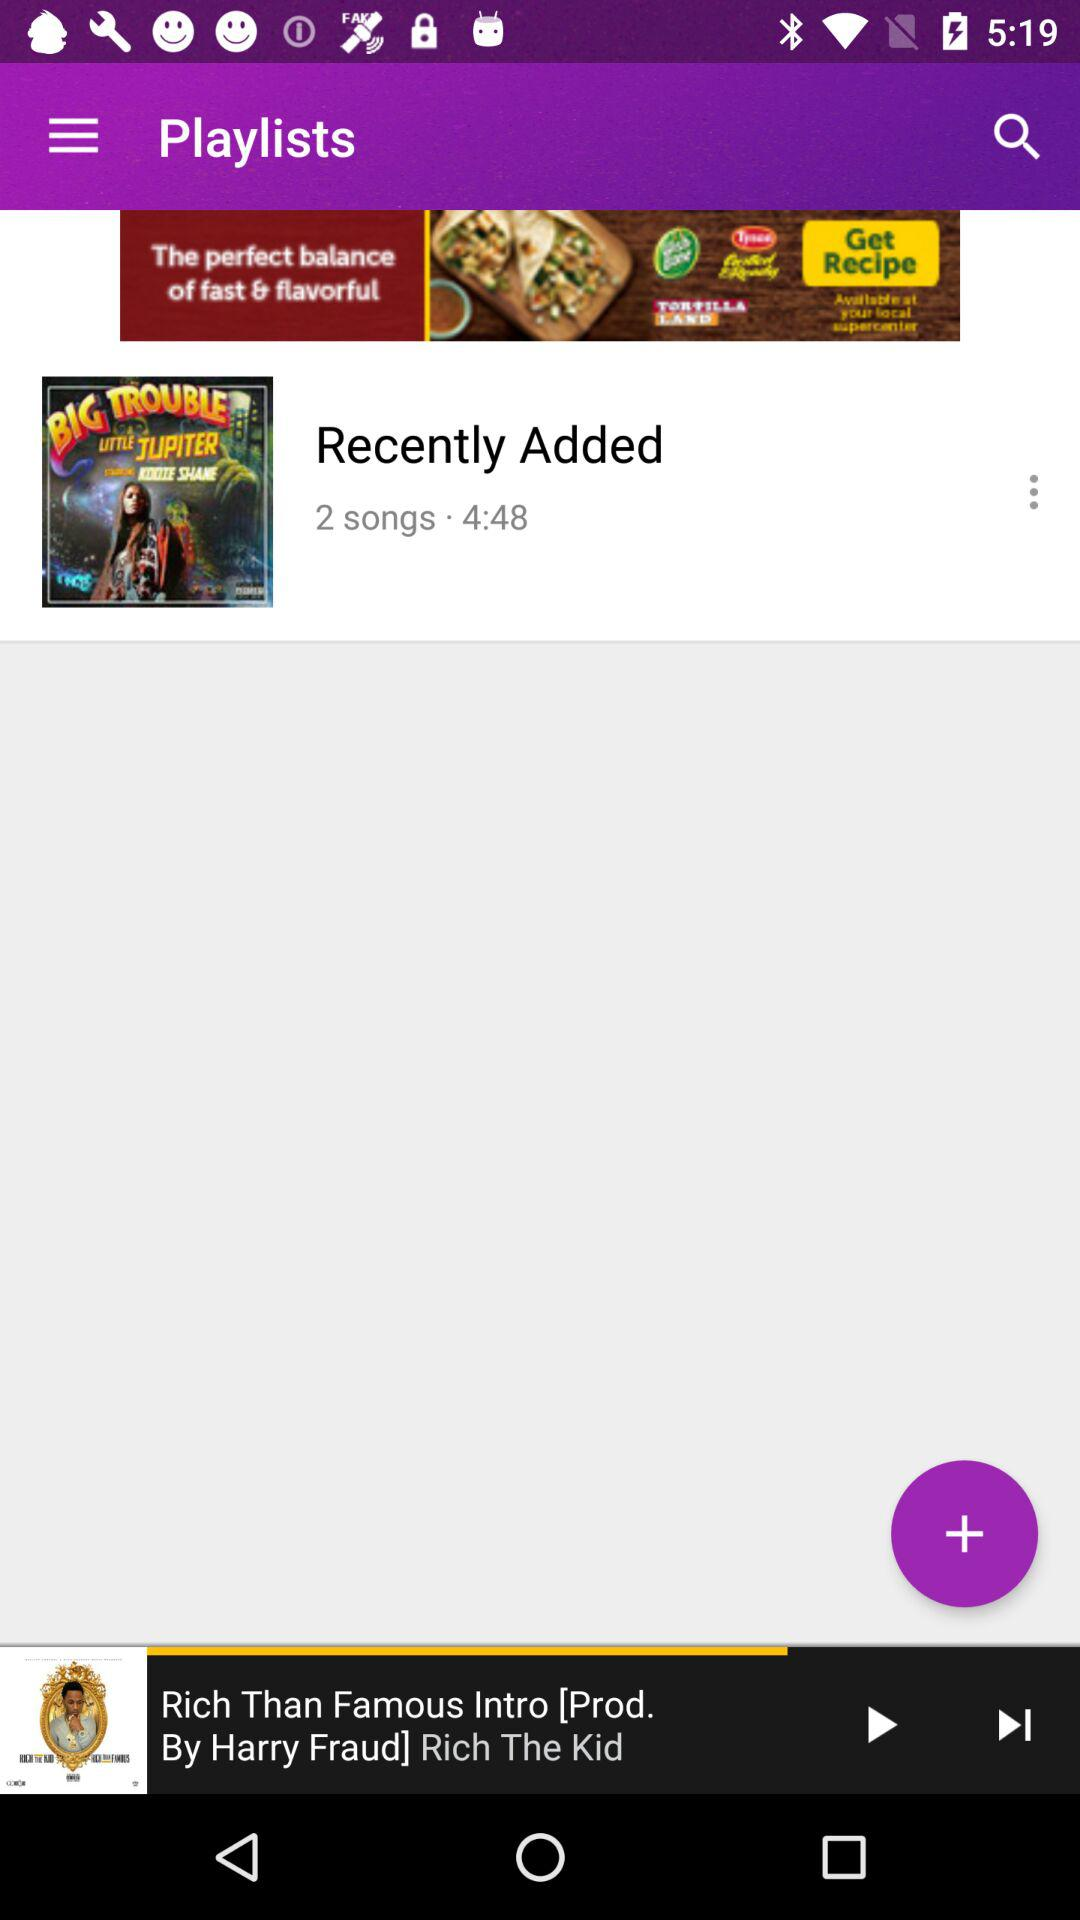Which song was last played? The last played song was "Rich Than Famous Intro". 